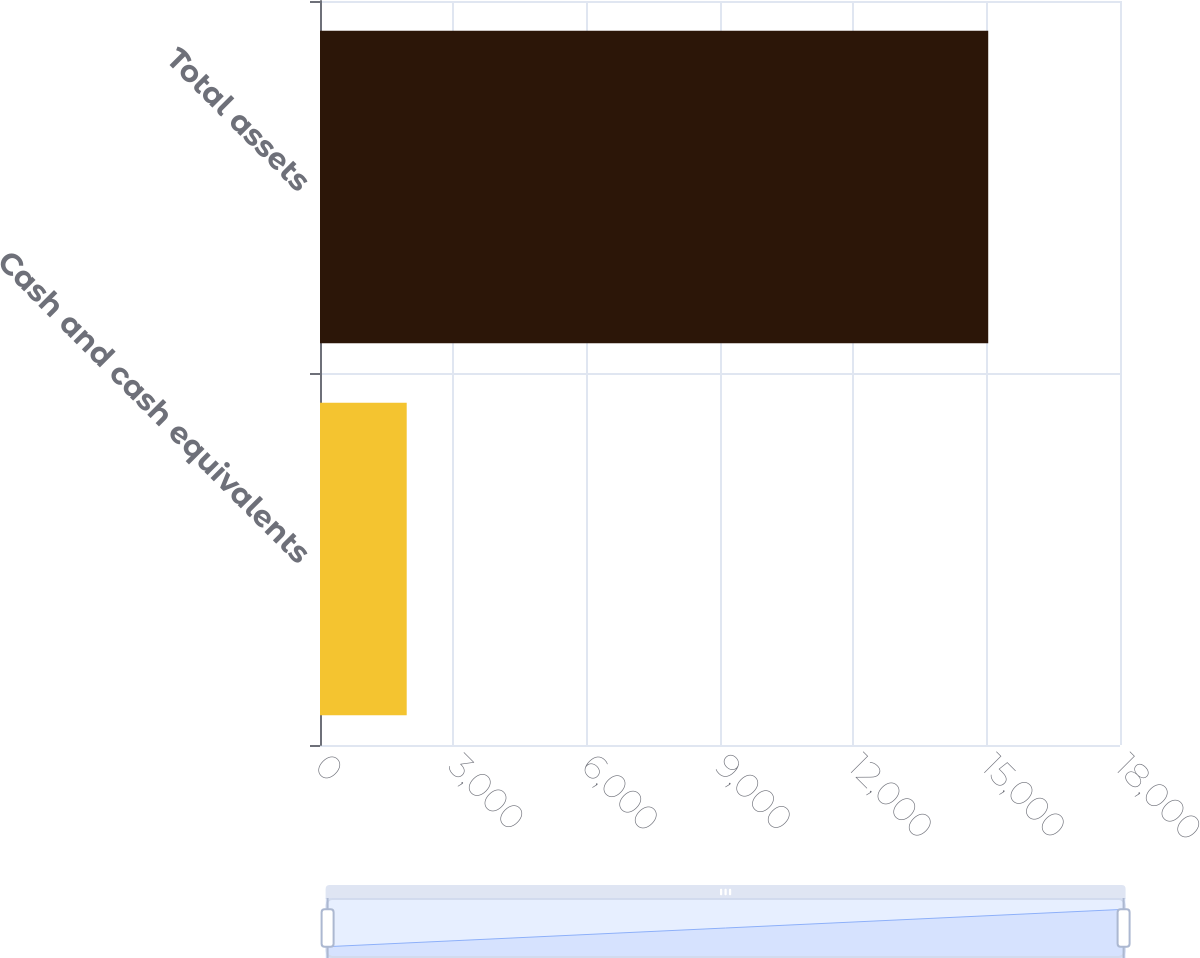Convert chart. <chart><loc_0><loc_0><loc_500><loc_500><bar_chart><fcel>Cash and cash equivalents<fcel>Total assets<nl><fcel>1951<fcel>15035<nl></chart> 